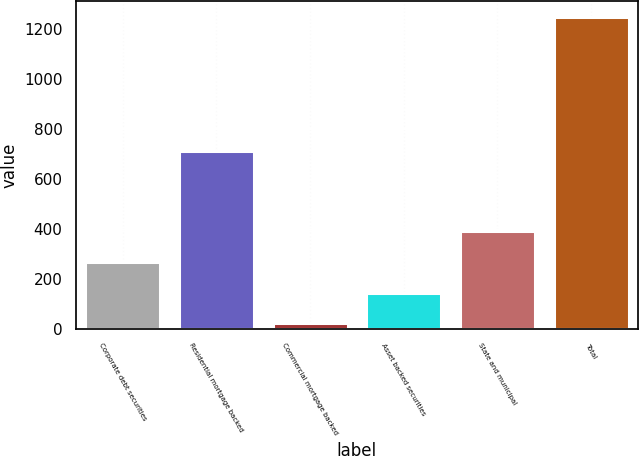Convert chart. <chart><loc_0><loc_0><loc_500><loc_500><bar_chart><fcel>Corporate debt securities<fcel>Residential mortgage backed<fcel>Commercial mortgage backed<fcel>Asset backed securities<fcel>State and municipal<fcel>Total<nl><fcel>267.8<fcel>712<fcel>23<fcel>145.4<fcel>390.2<fcel>1247<nl></chart> 